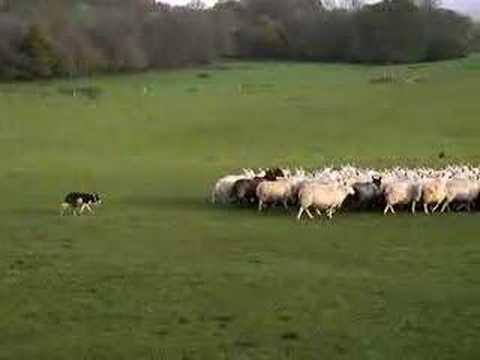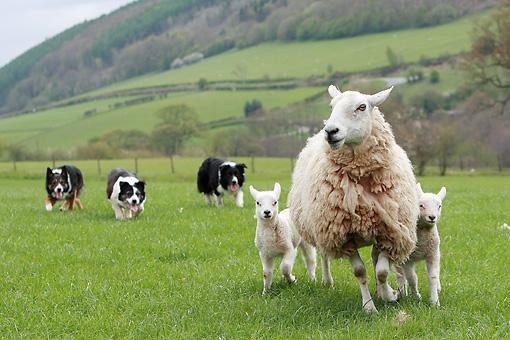The first image is the image on the left, the second image is the image on the right. Considering the images on both sides, is "In one of the images, there are exactly three sheep." valid? Answer yes or no. Yes. The first image is the image on the left, the second image is the image on the right. Given the left and right images, does the statement "A dog is positioned closest to the front of an image, with multiple sheep in the back." hold true? Answer yes or no. No. 